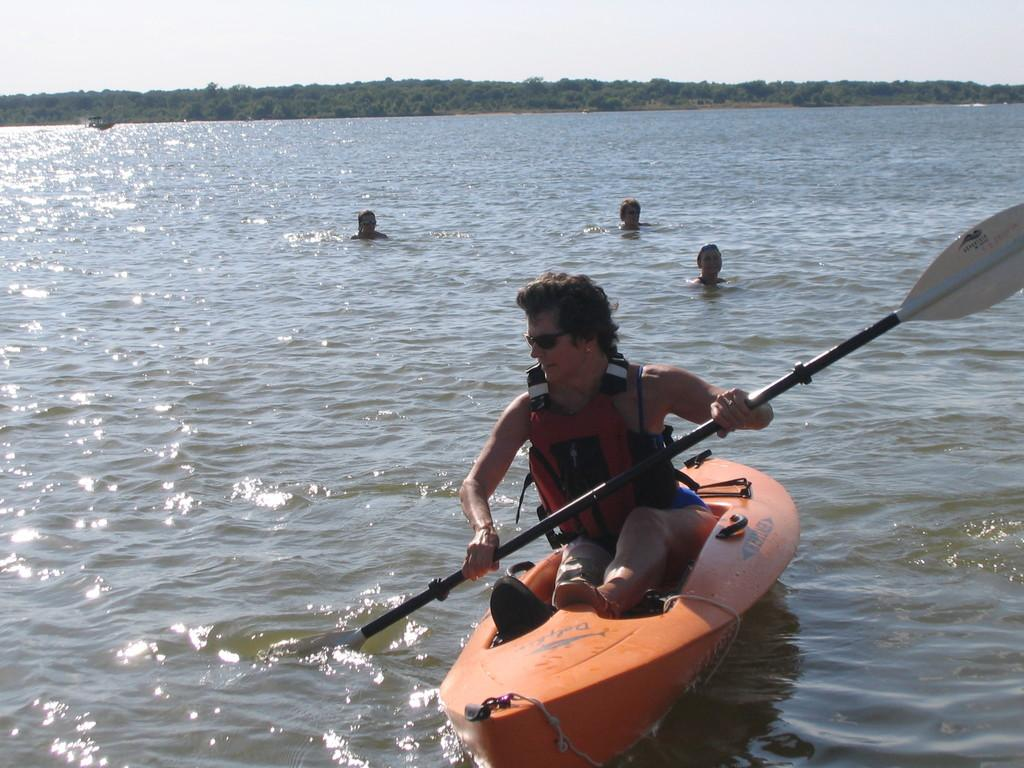What is the main subject of the image? The main subject of the image is a boat. Are there any people in the image? Yes, there is a group of people in the image. Can you describe the position of the man in the boat? A man is seated in the boat. What else can be seen in the image besides the boat and people? There are people in the water and trees in the background of the image. How many icicles are hanging from the boat in the image? There are no icicles present in the image; it is a boat on water with people around it. What type of house can be seen in the background of the image? There is no house visible in the background of the image; it features trees instead. 